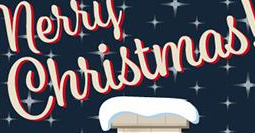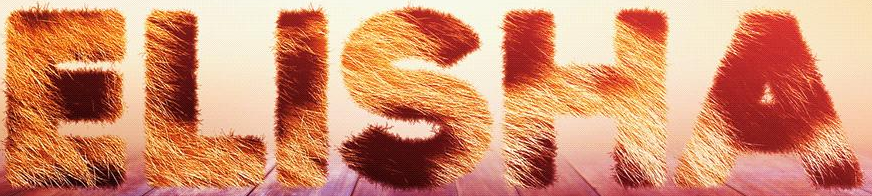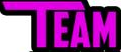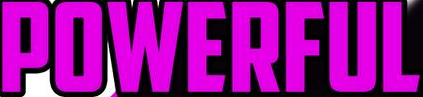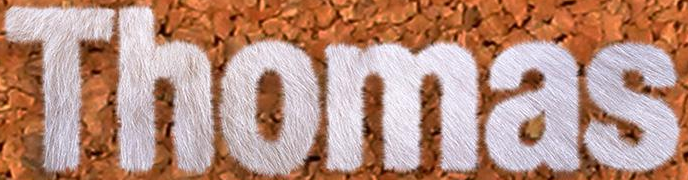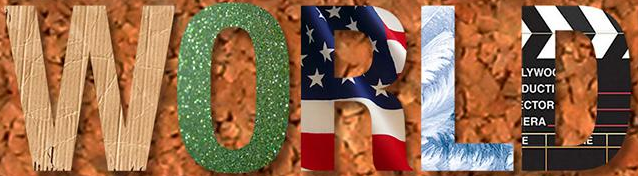What text is displayed in these images sequentially, separated by a semicolon? Christmas; ELISHA; TEAM; POWERFUL; Thomas; WORLD 